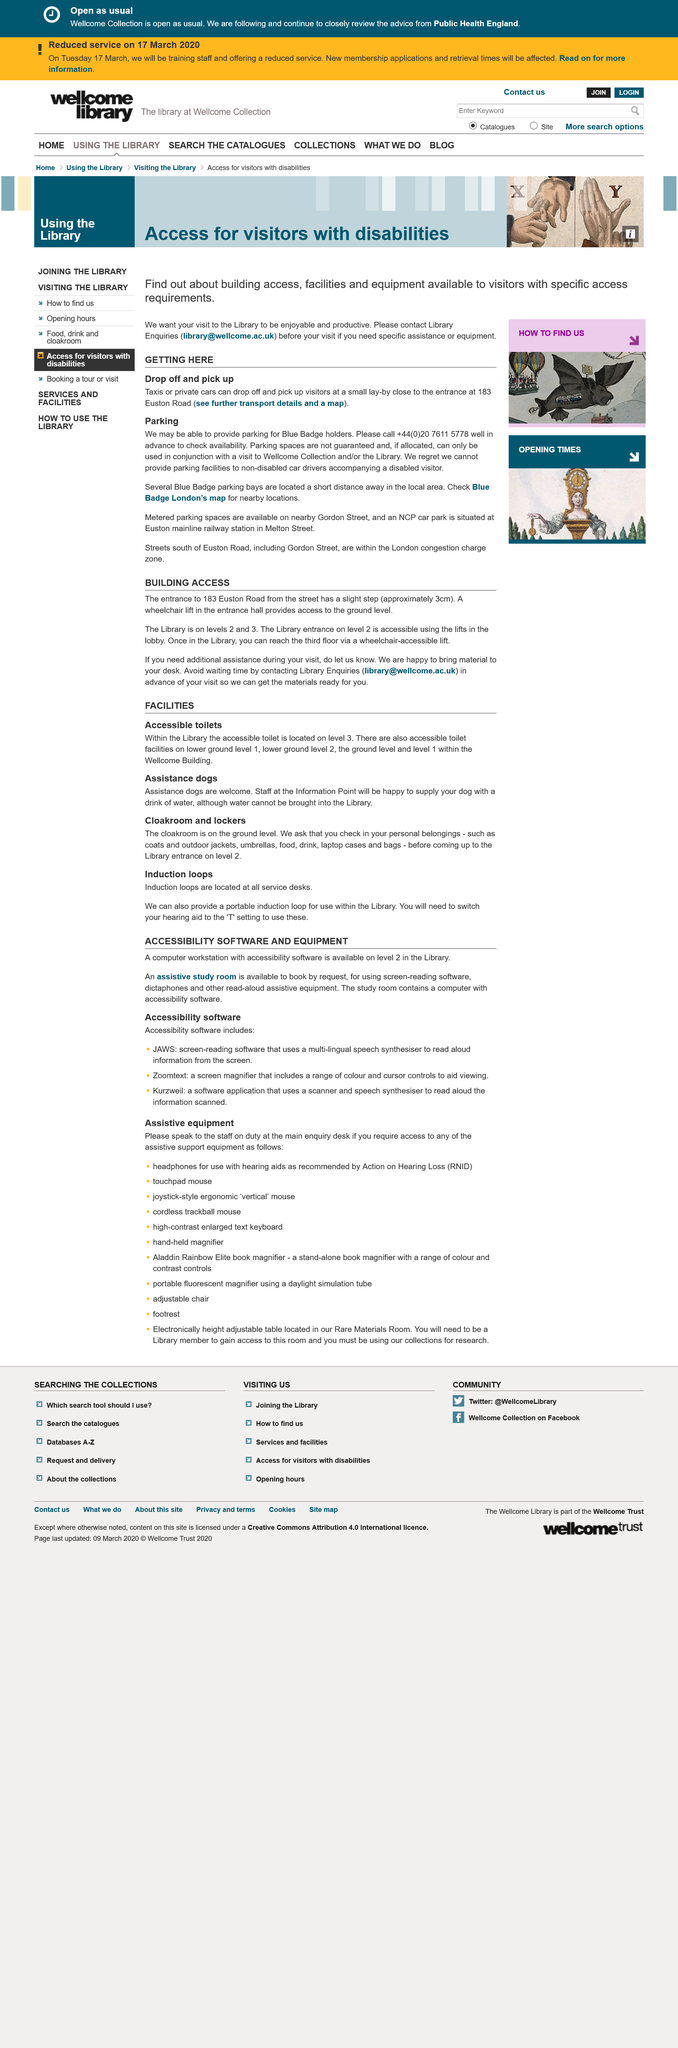Mention a couple of crucial points in this snapshot. The assistive study room can be booked by request and is available for use. It is imperative that staff at the Information Point are able to provide water to assistance dogs in the event of an emergency, as they are the primary source of support for these animals. The library located at 183 Euston Road is on levels 2 and 3. Assistance dogs are permitted to enter the library. Yes, it is possible for taxis to drop off visitors at a small lay-by. 